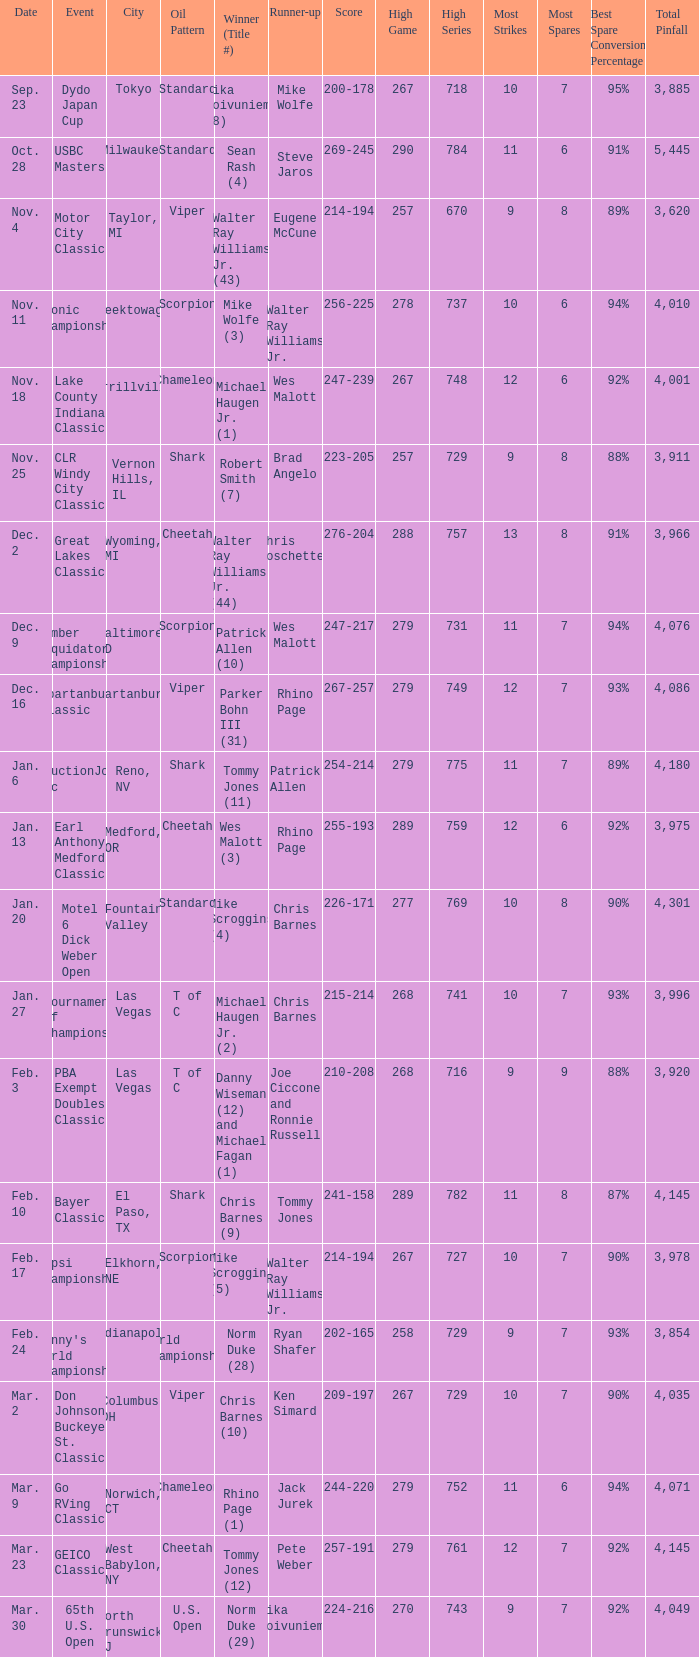Name the Date when has  robert smith (7)? Nov. 25. 